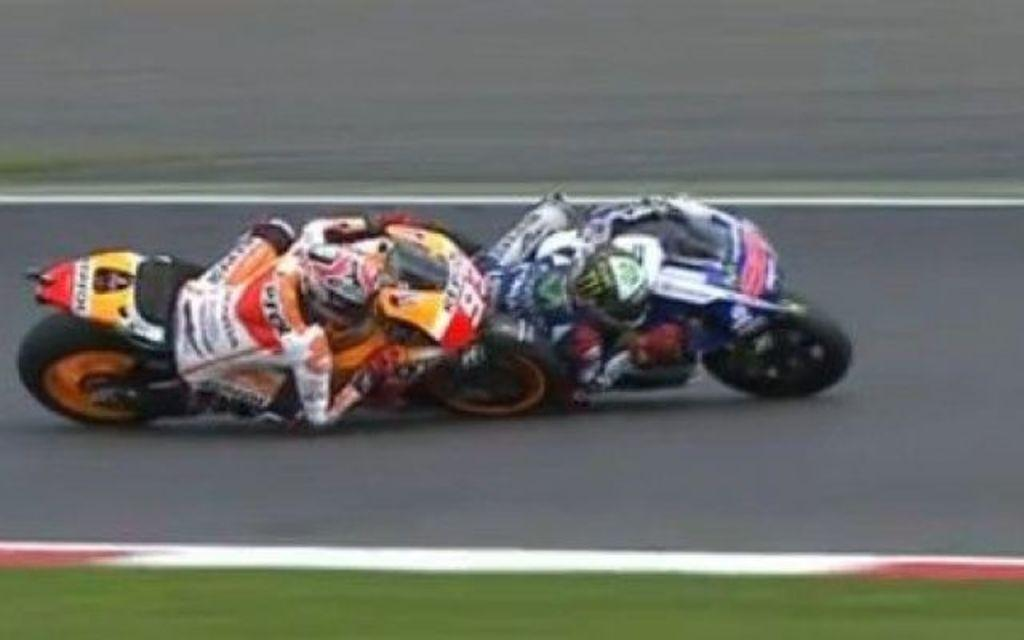How many people are in the image? There are two people in the image. What are the two people doing in the image? The two people are riding racing bikes in the image. Where are the bikes located in the image? The bikes are on the road in the image. What type of wax is being used to balance the bikes in the image? There is no wax present in the image, and the bikes are not being balanced in any unusual way. 